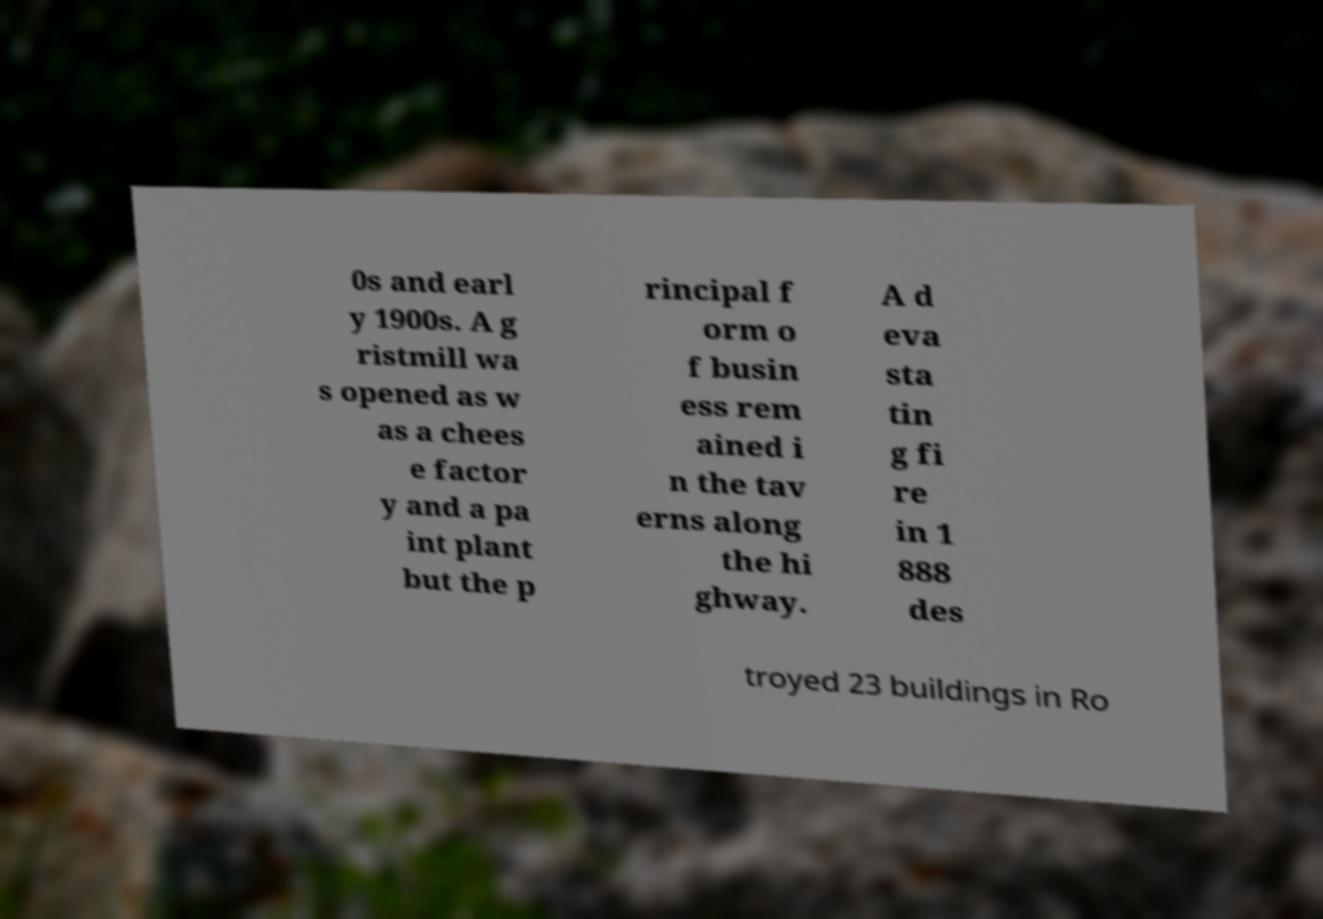There's text embedded in this image that I need extracted. Can you transcribe it verbatim? 0s and earl y 1900s. A g ristmill wa s opened as w as a chees e factor y and a pa int plant but the p rincipal f orm o f busin ess rem ained i n the tav erns along the hi ghway. A d eva sta tin g fi re in 1 888 des troyed 23 buildings in Ro 